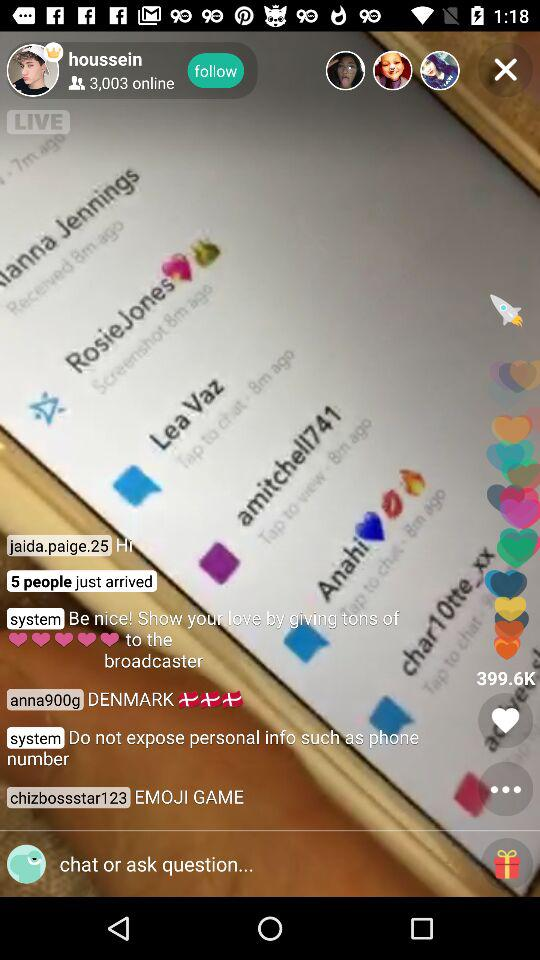How many people are online?
Answer the question using a single word or phrase. 3,003 